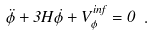<formula> <loc_0><loc_0><loc_500><loc_500>\ddot { \phi } + 3 H \dot { \phi } + V ^ { i n f } _ { \phi } = 0 \ .</formula> 